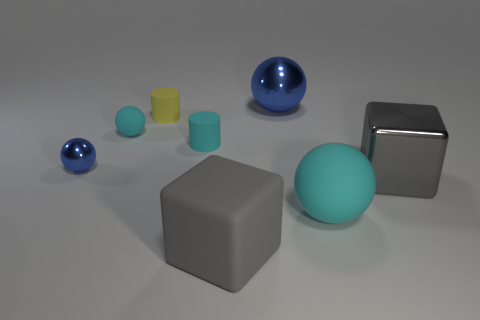Add 1 big purple shiny blocks. How many objects exist? 9 Subtract all blocks. How many objects are left? 6 Subtract 0 blue cubes. How many objects are left? 8 Subtract all yellow rubber cylinders. Subtract all big cubes. How many objects are left? 5 Add 3 big gray rubber objects. How many big gray rubber objects are left? 4 Add 3 rubber spheres. How many rubber spheres exist? 5 